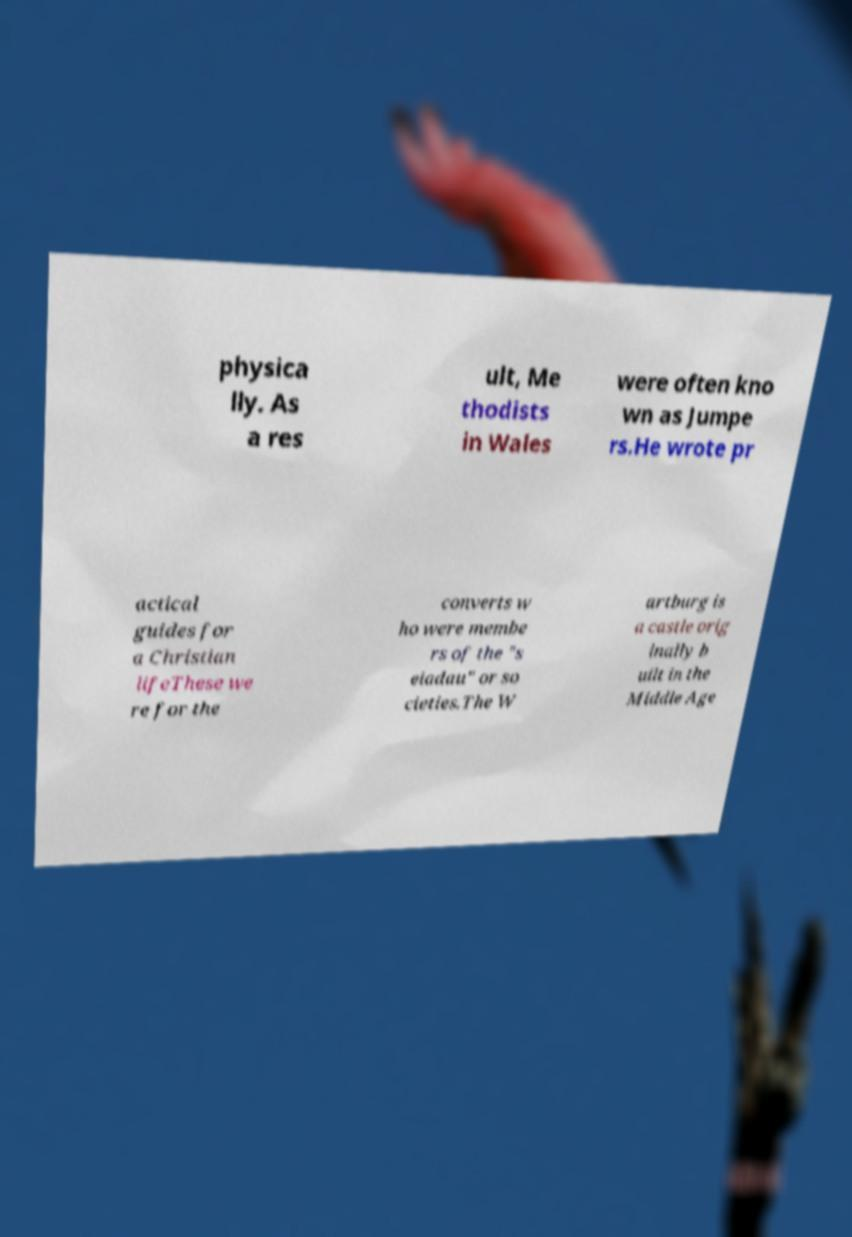Can you read and provide the text displayed in the image?This photo seems to have some interesting text. Can you extract and type it out for me? physica lly. As a res ult, Me thodists in Wales were often kno wn as Jumpe rs.He wrote pr actical guides for a Christian lifeThese we re for the converts w ho were membe rs of the "s eiadau" or so cieties.The W artburg is a castle orig inally b uilt in the Middle Age 